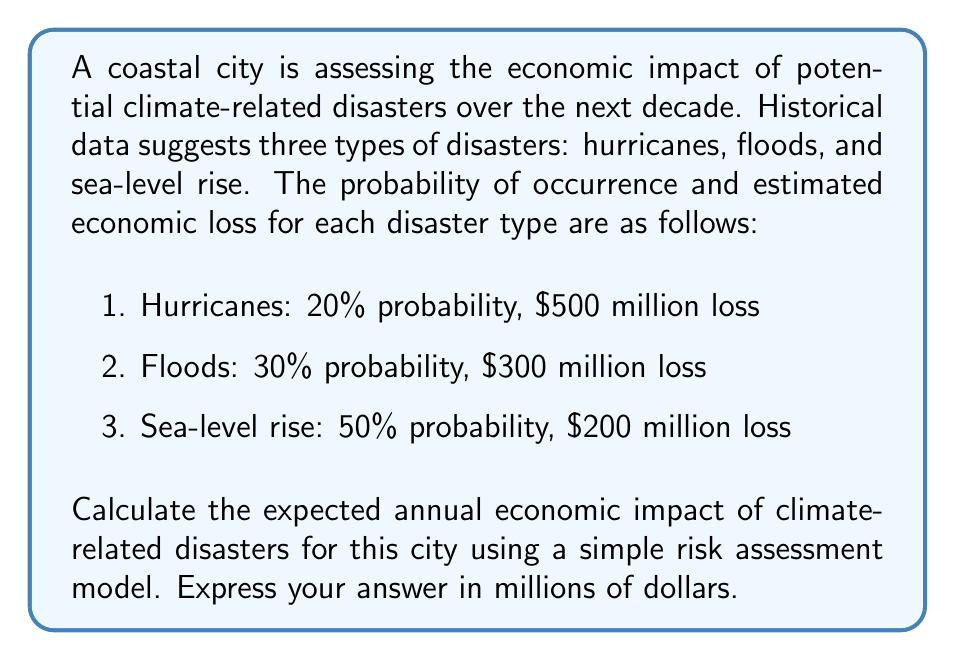Give your solution to this math problem. To calculate the expected annual economic impact, we'll use the concept of expected value from probability theory. The expected value is the sum of each possible outcome multiplied by its probability of occurrence.

Let's break it down step-by-step:

1. For each disaster type, calculate the expected loss:

   a) Hurricanes: 
      $E(\text{Hurricane}) = 0.20 \times \$500\text{ million} = \$100\text{ million}$

   b) Floods:
      $E(\text{Flood}) = 0.30 \times \$300\text{ million} = \$90\text{ million}$

   c) Sea-level rise:
      $E(\text{Sea-level rise}) = 0.50 \times \$200\text{ million} = \$100\text{ million}$

2. Sum up the expected losses for all disaster types:

   $E(\text{Total}) = E(\text{Hurricane}) + E(\text{Flood}) + E(\text{Sea-level rise})$
   
   $E(\text{Total}) = \$100\text{ million} + \$90\text{ million} + \$100\text{ million}$
   
   $E(\text{Total}) = \$290\text{ million}$

Therefore, the expected annual economic impact of climate-related disasters for this city is $290 million.
Answer: $290 million 